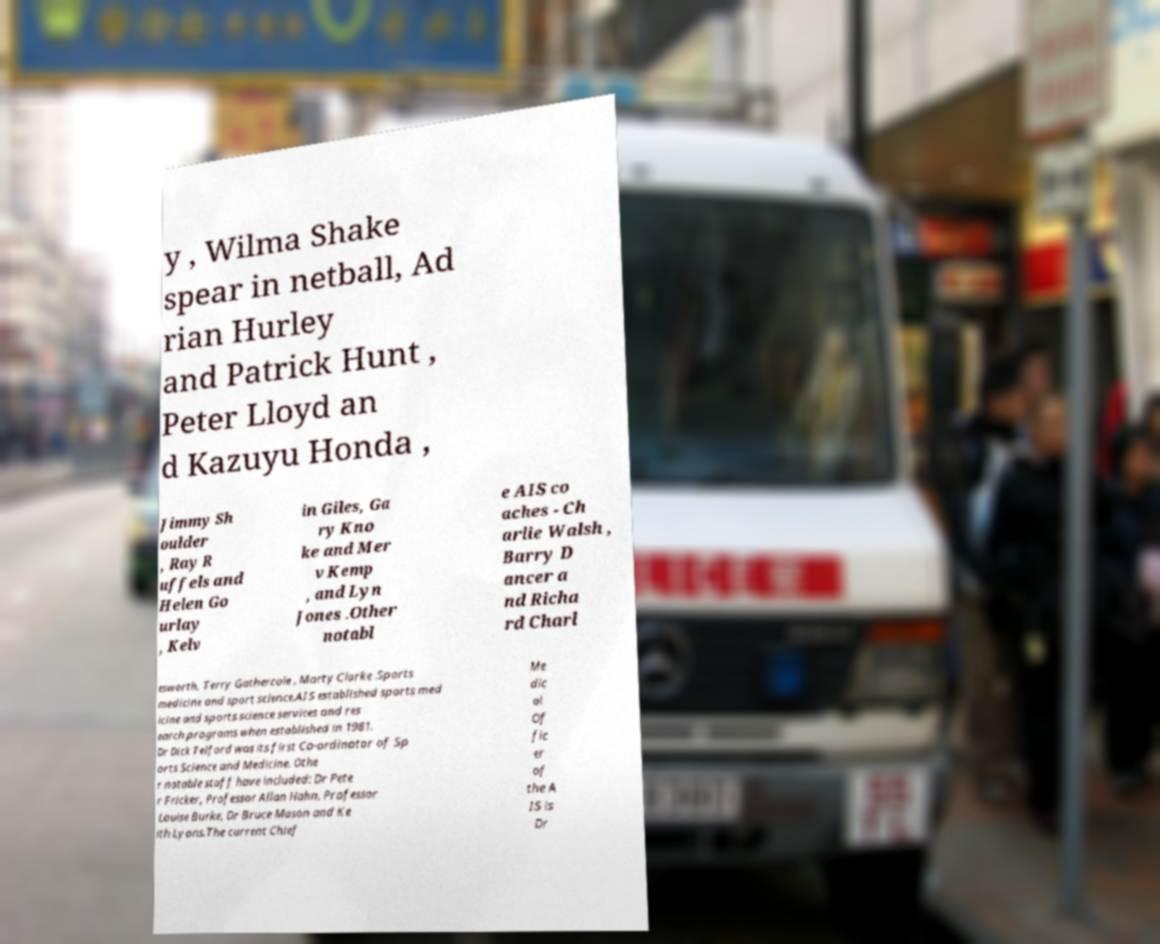Please read and relay the text visible in this image. What does it say? y , Wilma Shake spear in netball, Ad rian Hurley and Patrick Hunt , Peter Lloyd an d Kazuyu Honda , Jimmy Sh oulder , Ray R uffels and Helen Go urlay , Kelv in Giles, Ga ry Kno ke and Mer v Kemp , and Lyn Jones .Other notabl e AIS co aches - Ch arlie Walsh , Barry D ancer a nd Richa rd Charl esworth, Terry Gathercole , Marty Clarke .Sports medicine and sport science.AIS established sports med icine and sports science services and res earch programs when established in 1981. Dr Dick Telford was its first Co-ordinator of Sp orts Science and Medicine. Othe r notable staff have included: Dr Pete r Fricker, Professor Allan Hahn, Professor Louise Burke, Dr Bruce Mason and Ke ith Lyons.The current Chief Me dic al Of fic er of the A IS is Dr 